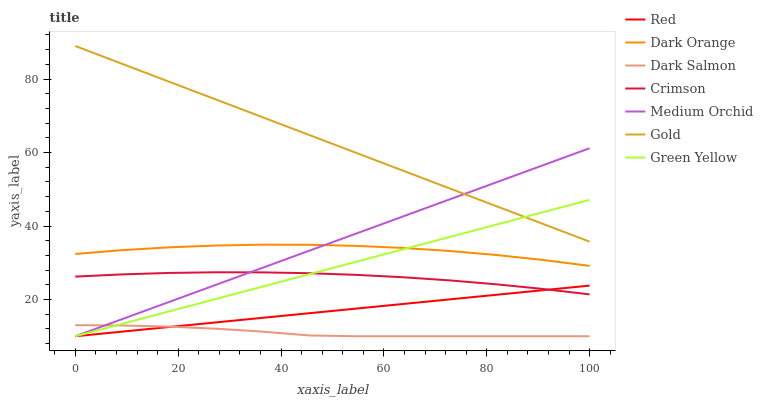Does Dark Salmon have the minimum area under the curve?
Answer yes or no. Yes. Does Gold have the maximum area under the curve?
Answer yes or no. Yes. Does Medium Orchid have the minimum area under the curve?
Answer yes or no. No. Does Medium Orchid have the maximum area under the curve?
Answer yes or no. No. Is Red the smoothest?
Answer yes or no. Yes. Is Dark Orange the roughest?
Answer yes or no. Yes. Is Gold the smoothest?
Answer yes or no. No. Is Gold the roughest?
Answer yes or no. No. Does Medium Orchid have the lowest value?
Answer yes or no. Yes. Does Gold have the lowest value?
Answer yes or no. No. Does Gold have the highest value?
Answer yes or no. Yes. Does Medium Orchid have the highest value?
Answer yes or no. No. Is Crimson less than Gold?
Answer yes or no. Yes. Is Gold greater than Dark Orange?
Answer yes or no. Yes. Does Gold intersect Green Yellow?
Answer yes or no. Yes. Is Gold less than Green Yellow?
Answer yes or no. No. Is Gold greater than Green Yellow?
Answer yes or no. No. Does Crimson intersect Gold?
Answer yes or no. No. 